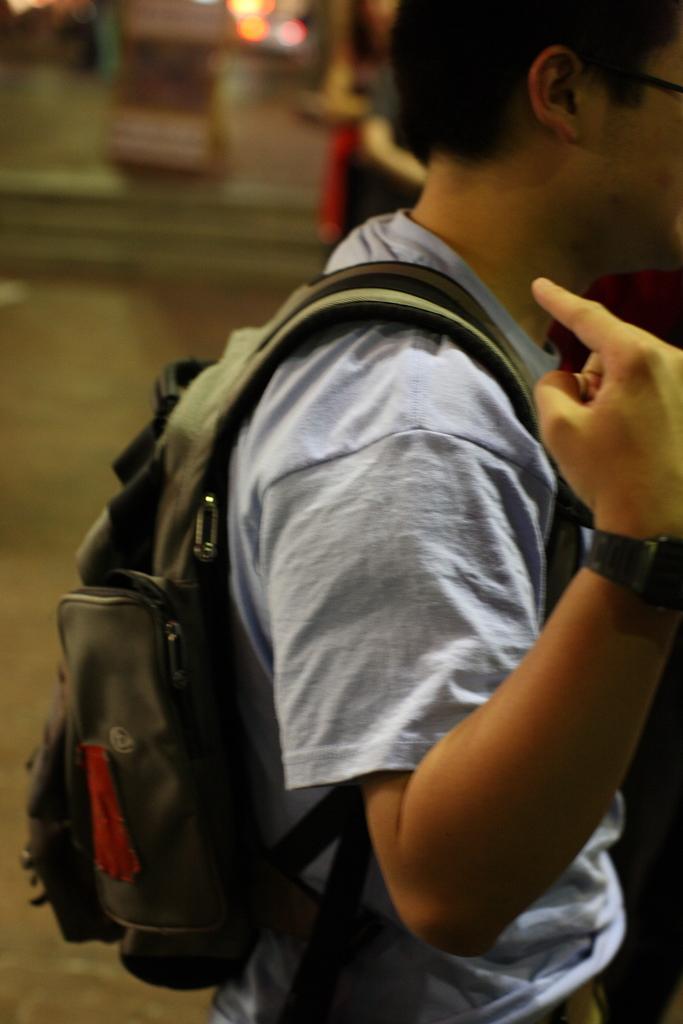Can you describe this image briefly? In this picture we can see man carrying bag worn watch, spectacle and in the background we can see some lights and it is blur. 